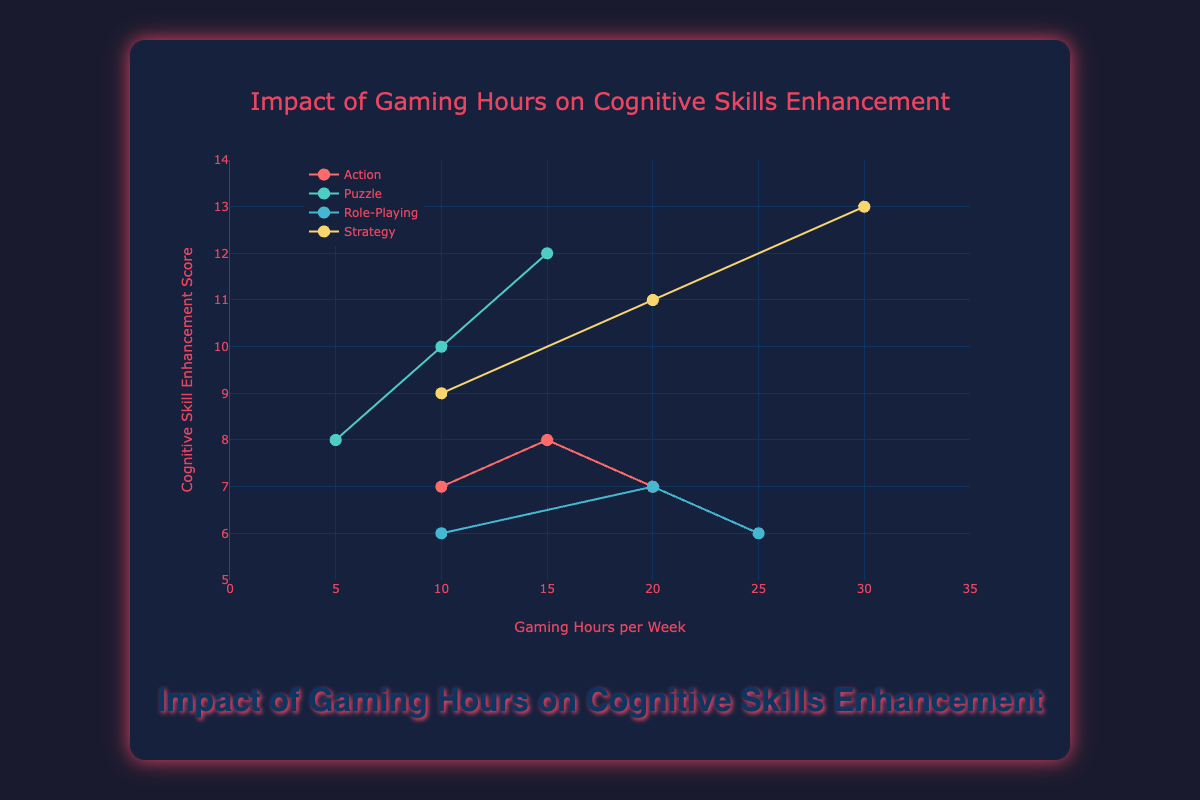What is the title of the figure? Look at the main heading displayed at the top center of the figure. It reads "Impact of Gaming Hours on Cognitive Skills Enhancement."
Answer: Impact of Gaming Hours on Cognitive Skills Enhancement How many data points are there for the Action genre in the figure? Count the individual markers (dots) for the Action genre. There are three data points for Action.
Answer: 3 Which game genre shows the highest Cognitive Skill Enhancement Score for 10 hours of gaming per week? Look at the y-axis values for the markers that are located at 10 hours on the x-axis. Puzzle genre has the highest score of 10.
Answer: Puzzle What is the range of Gaming Hours per Week shown in the figure? Look at the x-axis to determine the minimum and maximum values. The range is from 0 to 35 hours per week.
Answer: 0 to 35 What is the trend of Cognitive Skill Enhancement Scores for the Strategy genre as Gaming Hours per Week increases? Observe the trend line for the Strategy genre. The scores increase as the gaming hours increase.
Answer: Increase Which genre has the lowest starting score for Cognitive Skill Enhancement at 10 hours per week? Identify which genre has the lowest marker on the y-axis for 10 hours of gaming per week. Role-Playing has the lowest starting score of 6.
Answer: Role-Playing What are the differences in Cognitive Skill Enhancement Scores between Puzzle and Role-Playing genres at 10 hours per week? Look at the corresponding scores for each genre at 10 hours per week and subtract the Role-Playing score from the Puzzle score: 10 - 6 = 4.
Answer: 4 Do all genres show a positive trend in Cognitive Skill Enhancement as gaming hours increase? Compare the trend lines of all the genres. While Puzzle and Strategy show a clear positive trend, Action and Role-Playing do not show a consistent positive trend.
Answer: No Which genre has the most substantial increase in Cognitive Skill Enhancement Score from 10 to 30 hours per week? Evaluate the change in scores from 10 to 30 hours for each genre. Strategy increases from 9 to 13, which is the largest increase of +4.
Answer: Strategy By observing the scatter plot and trend lines, can we conclude that all genres enhance cognitive skills positively with the increase of gaming hours? No, only some genres like Puzzle and Strategy show a clear positive trend. Action and Role-Playing do not demonstrate a consistent positive effect.
Answer: No 